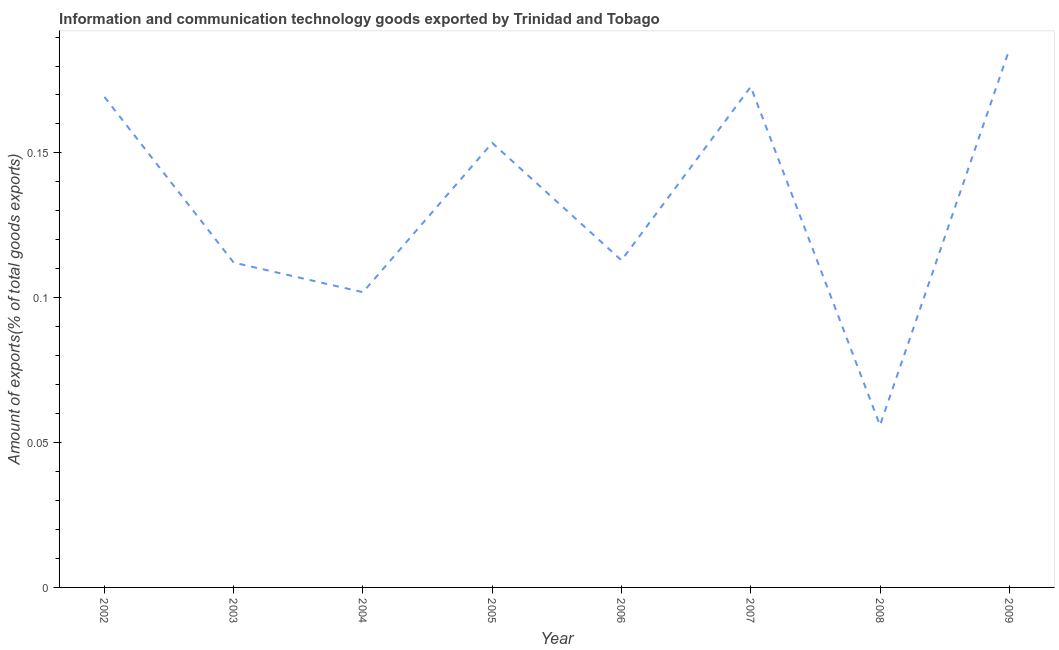What is the amount of ict goods exports in 2008?
Your response must be concise. 0.06. Across all years, what is the maximum amount of ict goods exports?
Offer a very short reply. 0.19. Across all years, what is the minimum amount of ict goods exports?
Provide a succinct answer. 0.06. What is the sum of the amount of ict goods exports?
Your answer should be compact. 1.06. What is the difference between the amount of ict goods exports in 2002 and 2009?
Offer a very short reply. -0.02. What is the average amount of ict goods exports per year?
Keep it short and to the point. 0.13. What is the median amount of ict goods exports?
Your answer should be very brief. 0.13. What is the ratio of the amount of ict goods exports in 2004 to that in 2006?
Your response must be concise. 0.9. What is the difference between the highest and the second highest amount of ict goods exports?
Provide a short and direct response. 0.01. Is the sum of the amount of ict goods exports in 2006 and 2007 greater than the maximum amount of ict goods exports across all years?
Provide a short and direct response. Yes. What is the difference between the highest and the lowest amount of ict goods exports?
Your response must be concise. 0.13. In how many years, is the amount of ict goods exports greater than the average amount of ict goods exports taken over all years?
Offer a terse response. 4. How many lines are there?
Your answer should be compact. 1. Does the graph contain grids?
Offer a very short reply. No. What is the title of the graph?
Give a very brief answer. Information and communication technology goods exported by Trinidad and Tobago. What is the label or title of the X-axis?
Provide a succinct answer. Year. What is the label or title of the Y-axis?
Provide a succinct answer. Amount of exports(% of total goods exports). What is the Amount of exports(% of total goods exports) of 2002?
Provide a succinct answer. 0.17. What is the Amount of exports(% of total goods exports) in 2003?
Provide a succinct answer. 0.11. What is the Amount of exports(% of total goods exports) of 2004?
Ensure brevity in your answer.  0.1. What is the Amount of exports(% of total goods exports) in 2005?
Your response must be concise. 0.15. What is the Amount of exports(% of total goods exports) of 2006?
Offer a terse response. 0.11. What is the Amount of exports(% of total goods exports) of 2007?
Offer a very short reply. 0.17. What is the Amount of exports(% of total goods exports) of 2008?
Your answer should be very brief. 0.06. What is the Amount of exports(% of total goods exports) of 2009?
Give a very brief answer. 0.19. What is the difference between the Amount of exports(% of total goods exports) in 2002 and 2003?
Make the answer very short. 0.06. What is the difference between the Amount of exports(% of total goods exports) in 2002 and 2004?
Offer a terse response. 0.07. What is the difference between the Amount of exports(% of total goods exports) in 2002 and 2005?
Make the answer very short. 0.02. What is the difference between the Amount of exports(% of total goods exports) in 2002 and 2006?
Offer a very short reply. 0.06. What is the difference between the Amount of exports(% of total goods exports) in 2002 and 2007?
Your answer should be very brief. -0. What is the difference between the Amount of exports(% of total goods exports) in 2002 and 2008?
Provide a succinct answer. 0.11. What is the difference between the Amount of exports(% of total goods exports) in 2002 and 2009?
Your answer should be compact. -0.02. What is the difference between the Amount of exports(% of total goods exports) in 2003 and 2004?
Your response must be concise. 0.01. What is the difference between the Amount of exports(% of total goods exports) in 2003 and 2005?
Ensure brevity in your answer.  -0.04. What is the difference between the Amount of exports(% of total goods exports) in 2003 and 2006?
Keep it short and to the point. -0. What is the difference between the Amount of exports(% of total goods exports) in 2003 and 2007?
Your answer should be very brief. -0.06. What is the difference between the Amount of exports(% of total goods exports) in 2003 and 2008?
Offer a very short reply. 0.06. What is the difference between the Amount of exports(% of total goods exports) in 2003 and 2009?
Offer a terse response. -0.07. What is the difference between the Amount of exports(% of total goods exports) in 2004 and 2005?
Keep it short and to the point. -0.05. What is the difference between the Amount of exports(% of total goods exports) in 2004 and 2006?
Your response must be concise. -0.01. What is the difference between the Amount of exports(% of total goods exports) in 2004 and 2007?
Provide a succinct answer. -0.07. What is the difference between the Amount of exports(% of total goods exports) in 2004 and 2008?
Your answer should be compact. 0.05. What is the difference between the Amount of exports(% of total goods exports) in 2004 and 2009?
Provide a short and direct response. -0.08. What is the difference between the Amount of exports(% of total goods exports) in 2005 and 2006?
Keep it short and to the point. 0.04. What is the difference between the Amount of exports(% of total goods exports) in 2005 and 2007?
Your response must be concise. -0.02. What is the difference between the Amount of exports(% of total goods exports) in 2005 and 2008?
Give a very brief answer. 0.1. What is the difference between the Amount of exports(% of total goods exports) in 2005 and 2009?
Provide a short and direct response. -0.03. What is the difference between the Amount of exports(% of total goods exports) in 2006 and 2007?
Your answer should be very brief. -0.06. What is the difference between the Amount of exports(% of total goods exports) in 2006 and 2008?
Your answer should be very brief. 0.06. What is the difference between the Amount of exports(% of total goods exports) in 2006 and 2009?
Your response must be concise. -0.07. What is the difference between the Amount of exports(% of total goods exports) in 2007 and 2008?
Keep it short and to the point. 0.12. What is the difference between the Amount of exports(% of total goods exports) in 2007 and 2009?
Your answer should be compact. -0.01. What is the difference between the Amount of exports(% of total goods exports) in 2008 and 2009?
Your response must be concise. -0.13. What is the ratio of the Amount of exports(% of total goods exports) in 2002 to that in 2003?
Give a very brief answer. 1.51. What is the ratio of the Amount of exports(% of total goods exports) in 2002 to that in 2004?
Give a very brief answer. 1.66. What is the ratio of the Amount of exports(% of total goods exports) in 2002 to that in 2005?
Keep it short and to the point. 1.1. What is the ratio of the Amount of exports(% of total goods exports) in 2002 to that in 2006?
Your answer should be compact. 1.5. What is the ratio of the Amount of exports(% of total goods exports) in 2002 to that in 2007?
Your answer should be compact. 0.98. What is the ratio of the Amount of exports(% of total goods exports) in 2002 to that in 2008?
Ensure brevity in your answer.  3.03. What is the ratio of the Amount of exports(% of total goods exports) in 2002 to that in 2009?
Your answer should be very brief. 0.91. What is the ratio of the Amount of exports(% of total goods exports) in 2003 to that in 2005?
Offer a terse response. 0.73. What is the ratio of the Amount of exports(% of total goods exports) in 2003 to that in 2007?
Provide a short and direct response. 0.65. What is the ratio of the Amount of exports(% of total goods exports) in 2003 to that in 2008?
Give a very brief answer. 2. What is the ratio of the Amount of exports(% of total goods exports) in 2003 to that in 2009?
Offer a very short reply. 0.6. What is the ratio of the Amount of exports(% of total goods exports) in 2004 to that in 2005?
Provide a succinct answer. 0.66. What is the ratio of the Amount of exports(% of total goods exports) in 2004 to that in 2006?
Your answer should be very brief. 0.9. What is the ratio of the Amount of exports(% of total goods exports) in 2004 to that in 2007?
Your answer should be very brief. 0.59. What is the ratio of the Amount of exports(% of total goods exports) in 2004 to that in 2008?
Give a very brief answer. 1.82. What is the ratio of the Amount of exports(% of total goods exports) in 2004 to that in 2009?
Provide a succinct answer. 0.55. What is the ratio of the Amount of exports(% of total goods exports) in 2005 to that in 2006?
Provide a succinct answer. 1.36. What is the ratio of the Amount of exports(% of total goods exports) in 2005 to that in 2007?
Ensure brevity in your answer.  0.89. What is the ratio of the Amount of exports(% of total goods exports) in 2005 to that in 2008?
Ensure brevity in your answer.  2.74. What is the ratio of the Amount of exports(% of total goods exports) in 2005 to that in 2009?
Provide a short and direct response. 0.83. What is the ratio of the Amount of exports(% of total goods exports) in 2006 to that in 2007?
Keep it short and to the point. 0.65. What is the ratio of the Amount of exports(% of total goods exports) in 2006 to that in 2008?
Keep it short and to the point. 2.02. What is the ratio of the Amount of exports(% of total goods exports) in 2006 to that in 2009?
Your answer should be very brief. 0.61. What is the ratio of the Amount of exports(% of total goods exports) in 2007 to that in 2008?
Provide a short and direct response. 3.09. What is the ratio of the Amount of exports(% of total goods exports) in 2007 to that in 2009?
Keep it short and to the point. 0.93. What is the ratio of the Amount of exports(% of total goods exports) in 2008 to that in 2009?
Ensure brevity in your answer.  0.3. 